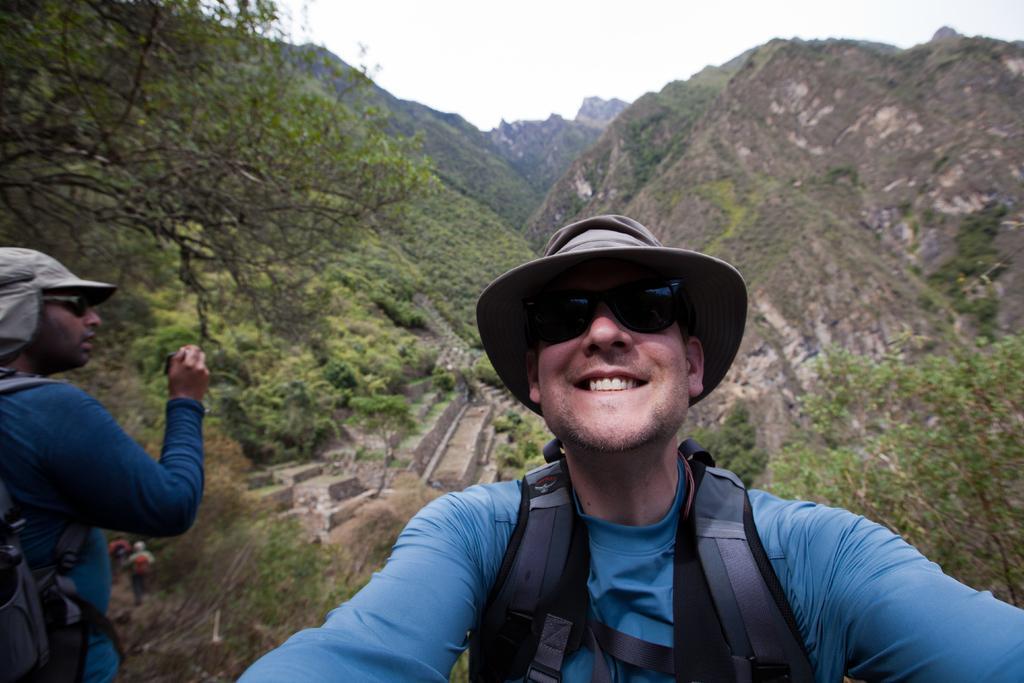Can you describe this image briefly? In this image we can see these two person wearing blue T-shirts, backpacks, glasses and hat are standing here and this person is holding a camera and this person is smiling. In the background, we can see hills, trees, steps and the sky. 